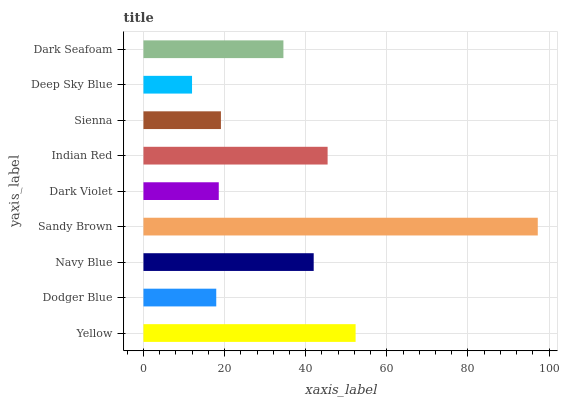Is Deep Sky Blue the minimum?
Answer yes or no. Yes. Is Sandy Brown the maximum?
Answer yes or no. Yes. Is Dodger Blue the minimum?
Answer yes or no. No. Is Dodger Blue the maximum?
Answer yes or no. No. Is Yellow greater than Dodger Blue?
Answer yes or no. Yes. Is Dodger Blue less than Yellow?
Answer yes or no. Yes. Is Dodger Blue greater than Yellow?
Answer yes or no. No. Is Yellow less than Dodger Blue?
Answer yes or no. No. Is Dark Seafoam the high median?
Answer yes or no. Yes. Is Dark Seafoam the low median?
Answer yes or no. Yes. Is Sienna the high median?
Answer yes or no. No. Is Deep Sky Blue the low median?
Answer yes or no. No. 